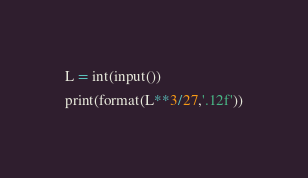Convert code to text. <code><loc_0><loc_0><loc_500><loc_500><_Python_>L = int(input())
print(format(L**3/27,'.12f'))</code> 